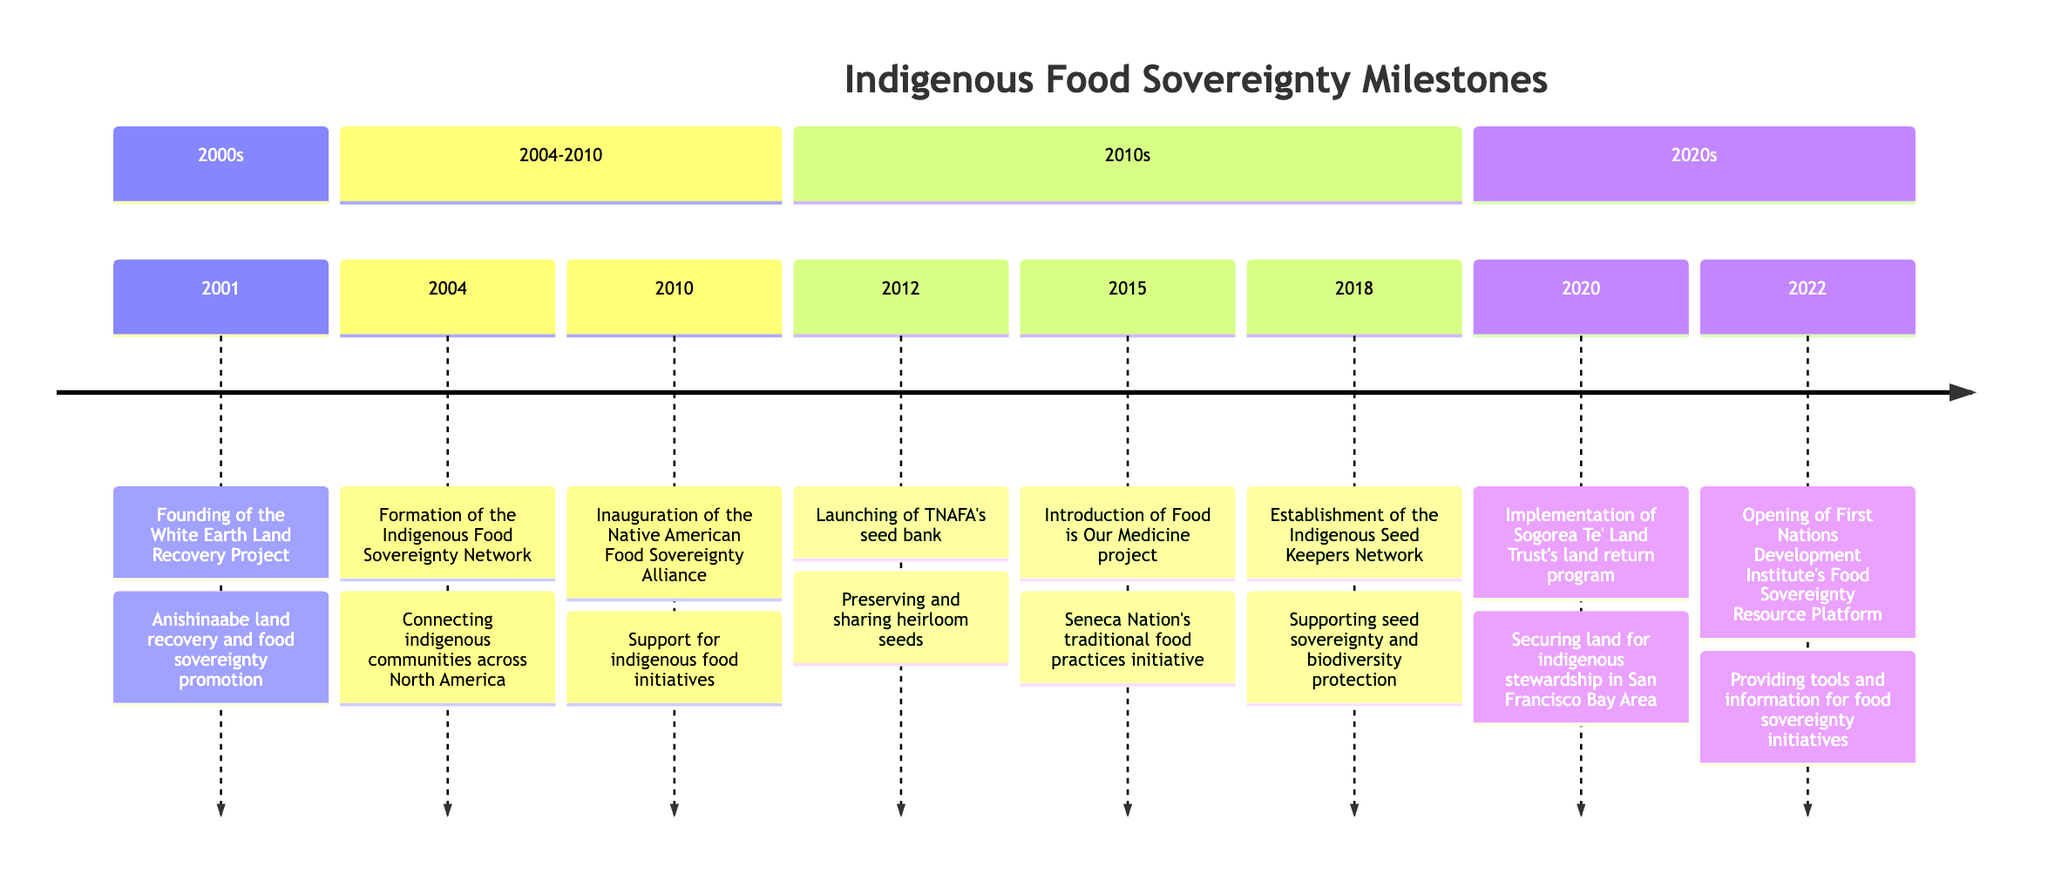What year was the White Earth Land Recovery Project founded? The timeline indicates that the White Earth Land Recovery Project was established in 2001.
Answer: 2001 How many milestones are listed in the timeline? By counting the events in the timeline, we find there are eight distinct milestones listed.
Answer: 8 What is the event associated with the year 2015? Referring to the timeline, the event for 2015 is the introduction of the 'Food is Our Medicine' project by the Seneca Nation.
Answer: Introduction of Food is Our Medicine project by the Seneca Nation Which organization launched a seed bank in 2012? The timeline states that the Traditional Native American Farmers Association launched a seed bank in 2012.
Answer: Traditional Native American Farmers Association What is the primary focus of the Indigenous Seed Keepers Network formed in 2018? According to the timeline, the Indigenous Seed Keepers Network primarily focuses on seed sovereignty and the protection of biodiversity.
Answer: Seed sovereignty and protection of biodiversity Which two events occurred in the 2010s? Analyzing the timeline, the two events that occurred in the 2010s include the launching of the seed bank in 2012 and the establishment of the Indigenous Seed Keepers Network in 2018.
Answer: Launching of TNAFA's seed bank, Establishment of the Indigenous Seed Keepers Network What is the main goal of the First Nations Development Institute's platform launched in 2022? The timeline depicts that the goal of the First Nations Development Institute's platform is to provide tools and information for food sovereignty initiatives.
Answer: Providing tools and information for food sovereignty initiatives In what year did the Sogorea Te' Land Trust implement its land return program? The timeline explicitly marks 2020 as the year when the Sogorea Te' Land Trust implemented its land return program.
Answer: 2020 